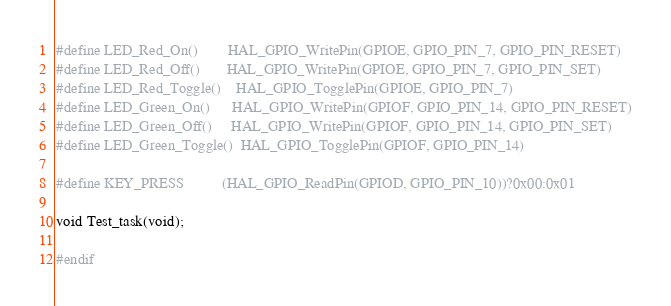<code> <loc_0><loc_0><loc_500><loc_500><_C_>#define LED_Red_On()        HAL_GPIO_WritePin(GPIOE, GPIO_PIN_7, GPIO_PIN_RESET)
#define LED_Red_Off()       HAL_GPIO_WritePin(GPIOE, GPIO_PIN_7, GPIO_PIN_SET)
#define LED_Red_Toggle()    HAL_GPIO_TogglePin(GPIOE, GPIO_PIN_7)
#define LED_Green_On()      HAL_GPIO_WritePin(GPIOF, GPIO_PIN_14, GPIO_PIN_RESET)
#define LED_Green_Off()     HAL_GPIO_WritePin(GPIOF, GPIO_PIN_14, GPIO_PIN_SET)
#define LED_Green_Toggle()  HAL_GPIO_TogglePin(GPIOF, GPIO_PIN_14)

#define KEY_PRESS          (HAL_GPIO_ReadPin(GPIOD, GPIO_PIN_10))?0x00:0x01

void Test_task(void);

#endif

</code> 